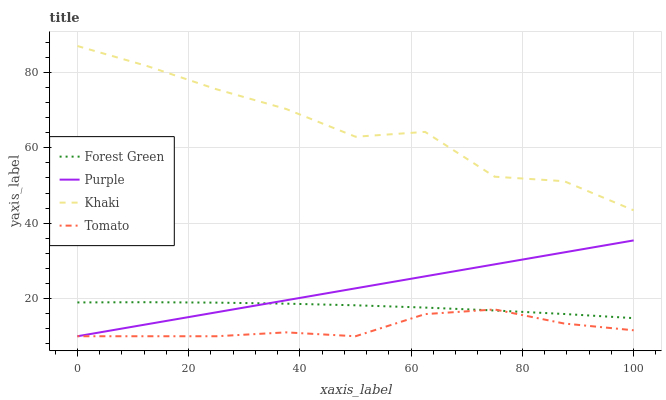Does Forest Green have the minimum area under the curve?
Answer yes or no. No. Does Forest Green have the maximum area under the curve?
Answer yes or no. No. Is Tomato the smoothest?
Answer yes or no. No. Is Tomato the roughest?
Answer yes or no. No. Does Forest Green have the lowest value?
Answer yes or no. No. Does Forest Green have the highest value?
Answer yes or no. No. Is Forest Green less than Khaki?
Answer yes or no. Yes. Is Khaki greater than Purple?
Answer yes or no. Yes. Does Forest Green intersect Khaki?
Answer yes or no. No. 